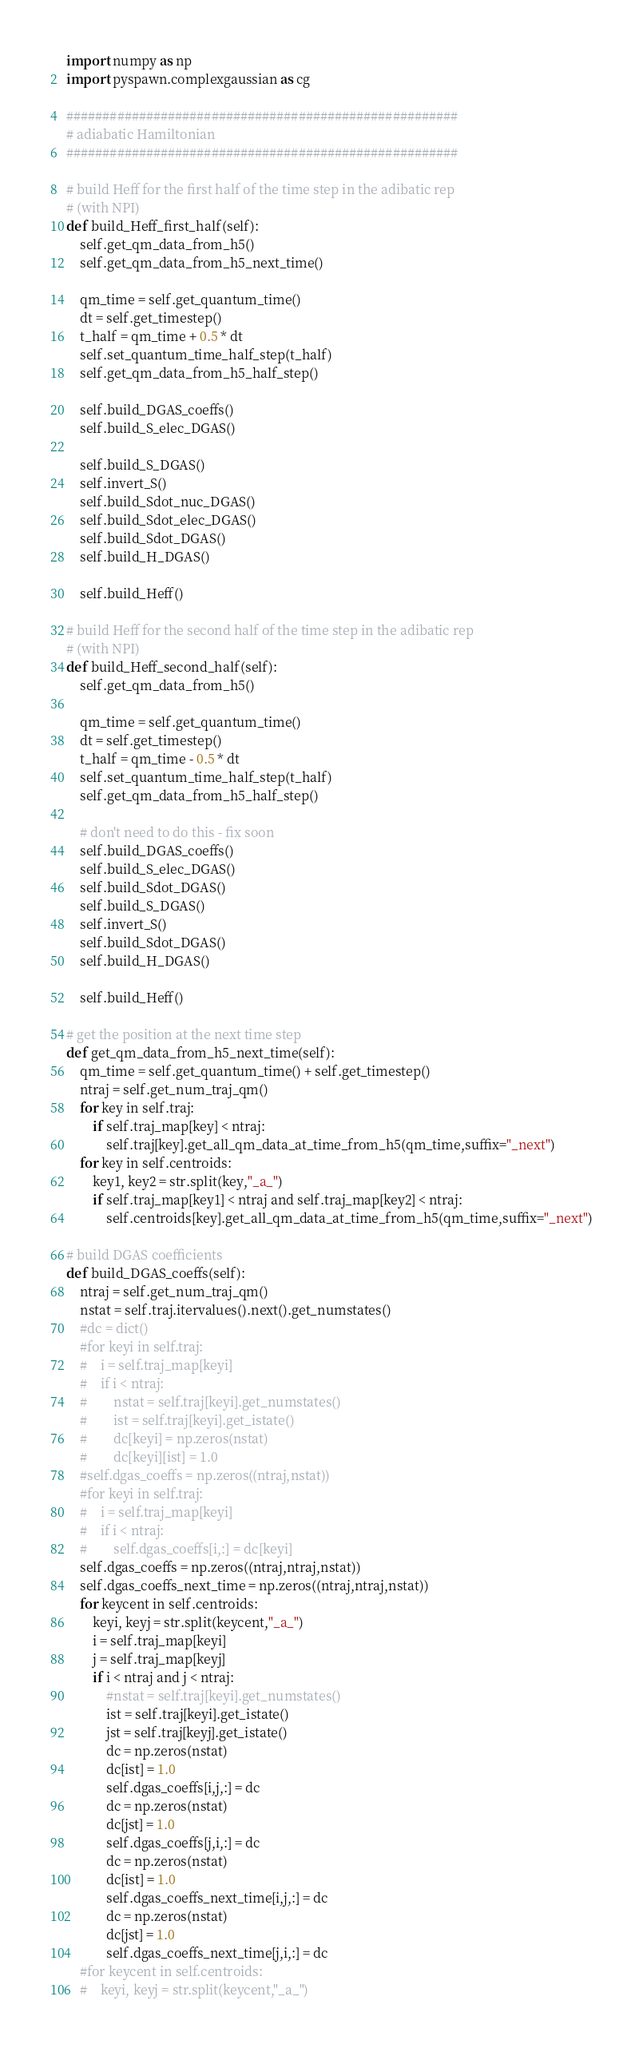<code> <loc_0><loc_0><loc_500><loc_500><_Python_>import numpy as np
import pyspawn.complexgaussian as cg

######################################################
# adiabatic Hamiltonian
######################################################

# build Heff for the first half of the time step in the adibatic rep
# (with NPI)
def build_Heff_first_half(self):
    self.get_qm_data_from_h5()
    self.get_qm_data_from_h5_next_time()
    
    qm_time = self.get_quantum_time()
    dt = self.get_timestep()
    t_half = qm_time + 0.5 * dt
    self.set_quantum_time_half_step(t_half)
    self.get_qm_data_from_h5_half_step()        

    self.build_DGAS_coeffs()
    self.build_S_elec_DGAS()
    
    self.build_S_DGAS()
    self.invert_S()
    self.build_Sdot_nuc_DGAS()
    self.build_Sdot_elec_DGAS()
    self.build_Sdot_DGAS()
    self.build_H_DGAS()
    
    self.build_Heff()
        
# build Heff for the second half of the time step in the adibatic rep
# (with NPI)
def build_Heff_second_half(self):
    self.get_qm_data_from_h5()
    
    qm_time = self.get_quantum_time()
    dt = self.get_timestep()
    t_half = qm_time - 0.5 * dt
    self.set_quantum_time_half_step(t_half)
    self.get_qm_data_from_h5_half_step()        

    # don't need to do this - fix soon
    self.build_DGAS_coeffs()
    self.build_S_elec_DGAS()
    self.build_Sdot_DGAS()
    self.build_S_DGAS()
    self.invert_S()
    self.build_Sdot_DGAS()
    self.build_H_DGAS()
    
    self.build_Heff()

# get the position at the next time step
def get_qm_data_from_h5_next_time(self):
    qm_time = self.get_quantum_time() + self.get_timestep()
    ntraj = self.get_num_traj_qm()
    for key in self.traj:
        if self.traj_map[key] < ntraj:
            self.traj[key].get_all_qm_data_at_time_from_h5(qm_time,suffix="_next")
    for key in self.centroids:
        key1, key2 = str.split(key,"_a_")
        if self.traj_map[key1] < ntraj and self.traj_map[key2] < ntraj:
            self.centroids[key].get_all_qm_data_at_time_from_h5(qm_time,suffix="_next")

# build DGAS coefficients
def build_DGAS_coeffs(self):
    ntraj = self.get_num_traj_qm()
    nstat = self.traj.itervalues().next().get_numstates()
    #dc = dict()
    #for keyi in self.traj:
    #    i = self.traj_map[keyi]
    #    if i < ntraj:
    #        nstat = self.traj[keyi].get_numstates()
    #        ist = self.traj[keyi].get_istate()
    #        dc[keyi] = np.zeros(nstat)
    #        dc[keyi][ist] = 1.0
    #self.dgas_coeffs = np.zeros((ntraj,nstat))
    #for keyi in self.traj:
    #    i = self.traj_map[keyi]
    #    if i < ntraj:
    #        self.dgas_coeffs[i,:] = dc[keyi]
    self.dgas_coeffs = np.zeros((ntraj,ntraj,nstat))
    self.dgas_coeffs_next_time = np.zeros((ntraj,ntraj,nstat))
    for keycent in self.centroids:
        keyi, keyj = str.split(keycent,"_a_")
        i = self.traj_map[keyi]
        j = self.traj_map[keyj]
        if i < ntraj and j < ntraj:
            #nstat = self.traj[keyi].get_numstates()
            ist = self.traj[keyi].get_istate()
            jst = self.traj[keyj].get_istate()
            dc = np.zeros(nstat)
            dc[ist] = 1.0
            self.dgas_coeffs[i,j,:] = dc
            dc = np.zeros(nstat)
            dc[jst] = 1.0
            self.dgas_coeffs[j,i,:] = dc
            dc = np.zeros(nstat)
            dc[ist] = 1.0
            self.dgas_coeffs_next_time[i,j,:] = dc
            dc = np.zeros(nstat)
            dc[jst] = 1.0
            self.dgas_coeffs_next_time[j,i,:] = dc
    #for keycent in self.centroids:
    #    keyi, keyj = str.split(keycent,"_a_")</code> 